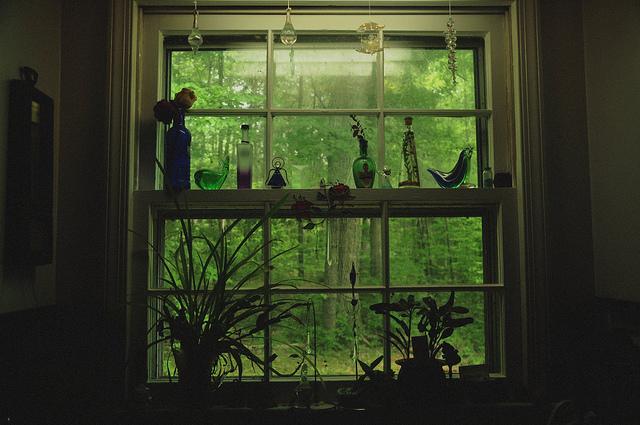What movie is this from?
Concise answer only. No movie. How many panes of. glass were used for. the windows?
Give a very brief answer. 12. How many houseplants are there?
Concise answer only. 2. Is there a teddy bear?
Short answer required. No. What color are the tree's leaves outside?
Short answer required. Green. 